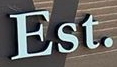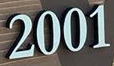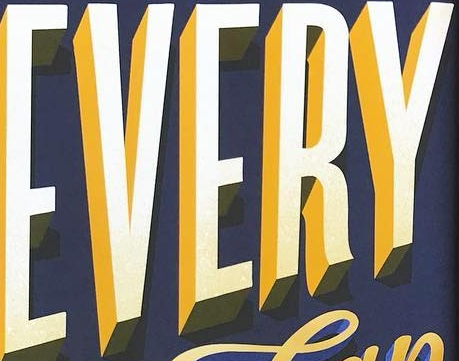Identify the words shown in these images in order, separated by a semicolon. Est.; 2001; EVERY 